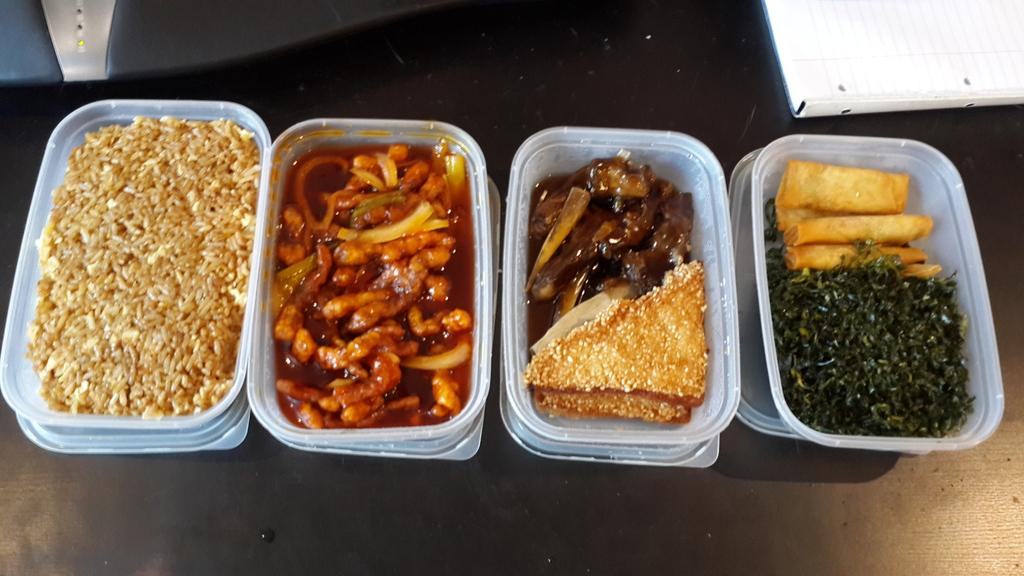How many boxes are visible in the image? There are four boxes in the image. What is inside the boxes? The boxes contain food. Where are the boxes located? The boxes are placed on a table. What type of trousers are hanging on the wall in the image? There are no trousers present in the image; it only features four boxes containing food placed on a table. 